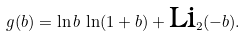Convert formula to latex. <formula><loc_0><loc_0><loc_500><loc_500>g ( b ) = \ln b \, \ln ( 1 + b ) + \text {Li} _ { 2 } ( - b ) .</formula> 